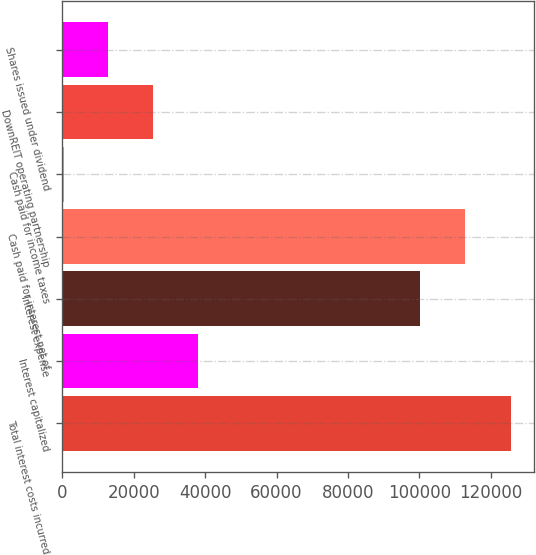<chart> <loc_0><loc_0><loc_500><loc_500><bar_chart><fcel>Total interest costs incurred<fcel>Interest capitalized<fcel>Interest expense<fcel>Cash paid for interest net of<fcel>Cash paid for income taxes<fcel>DownREIT operating partnership<fcel>Shares issued under dividend<nl><fcel>125684<fcel>37951.6<fcel>100125<fcel>112658<fcel>352<fcel>25418.4<fcel>12885.2<nl></chart> 